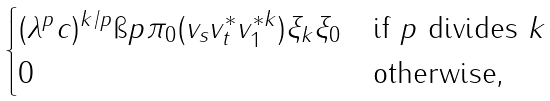Convert formula to latex. <formula><loc_0><loc_0><loc_500><loc_500>\begin{cases} ( \lambda ^ { p } c ) ^ { k / p } \i p { \pi _ { 0 } ( v _ { s } v _ { t } ^ { * } v _ { 1 } ^ { * k } ) \xi _ { k } } { \xi _ { 0 } } & \text {if $p$ divides $k$} \\ 0 & \text {otherwise,} \end{cases}</formula> 